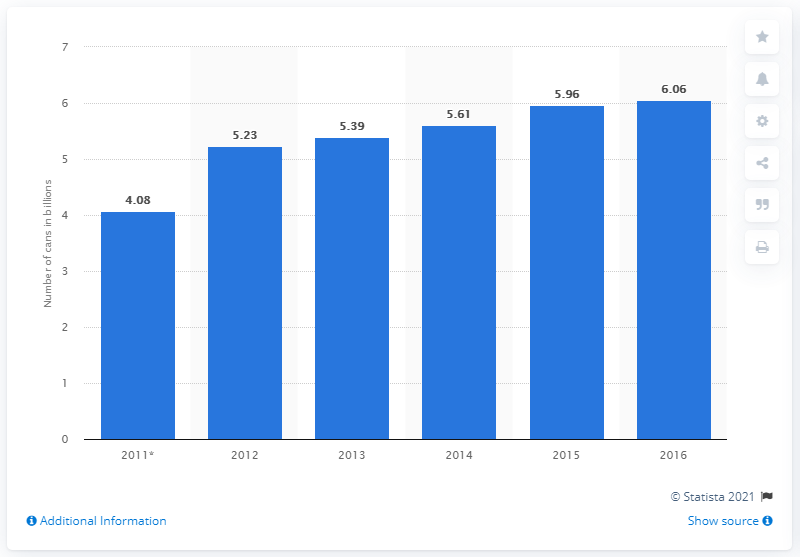Indicate a few pertinent items in this graphic. In 2016, a total of 6,060,000 cans of Red Bull were sold worldwide. 